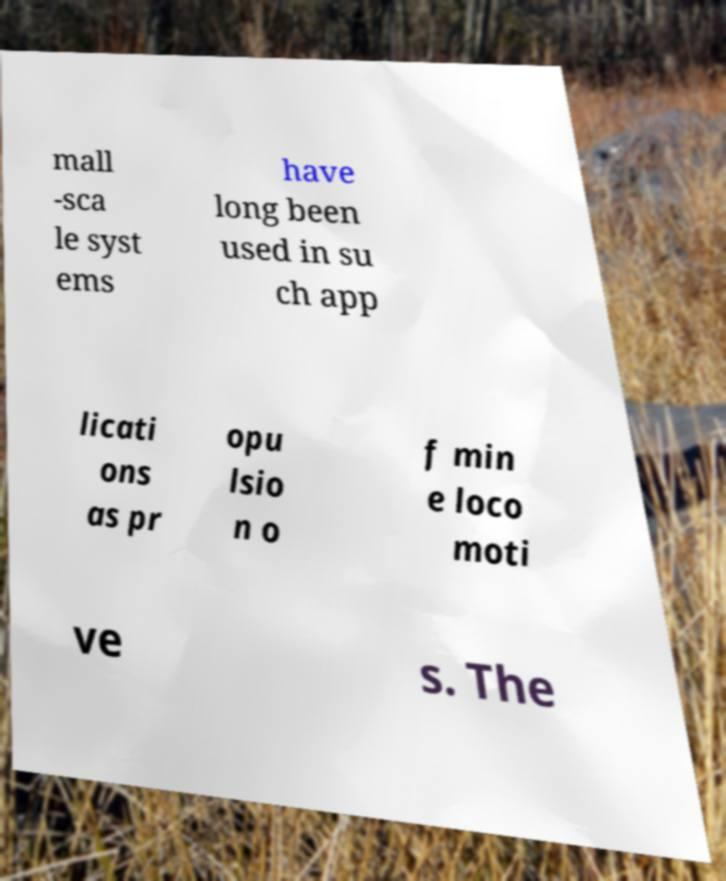I need the written content from this picture converted into text. Can you do that? mall -sca le syst ems have long been used in su ch app licati ons as pr opu lsio n o f min e loco moti ve s. The 